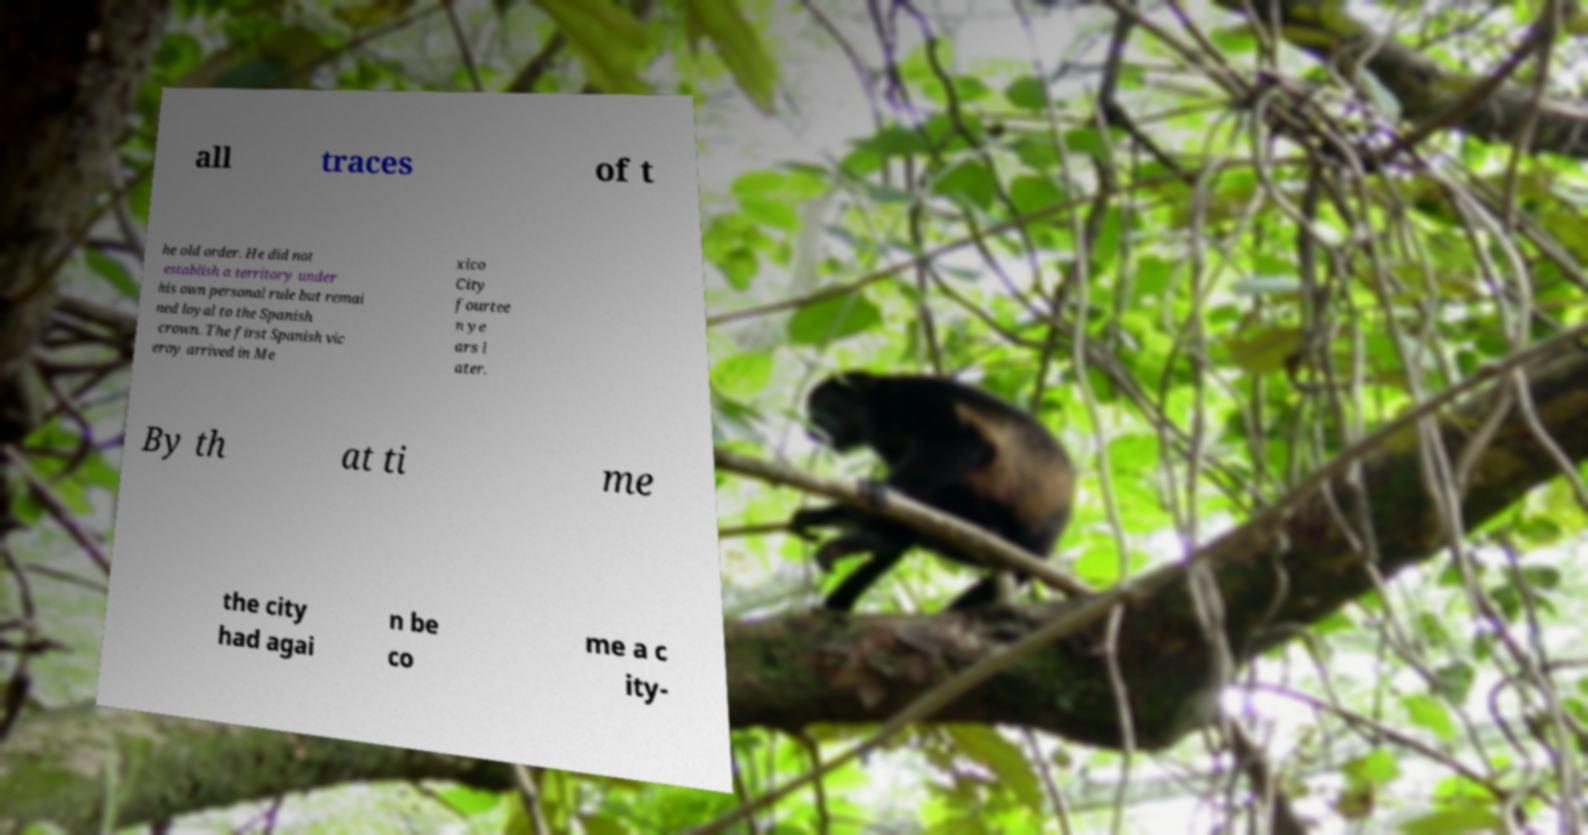Can you read and provide the text displayed in the image?This photo seems to have some interesting text. Can you extract and type it out for me? all traces of t he old order. He did not establish a territory under his own personal rule but remai ned loyal to the Spanish crown. The first Spanish vic eroy arrived in Me xico City fourtee n ye ars l ater. By th at ti me the city had agai n be co me a c ity- 